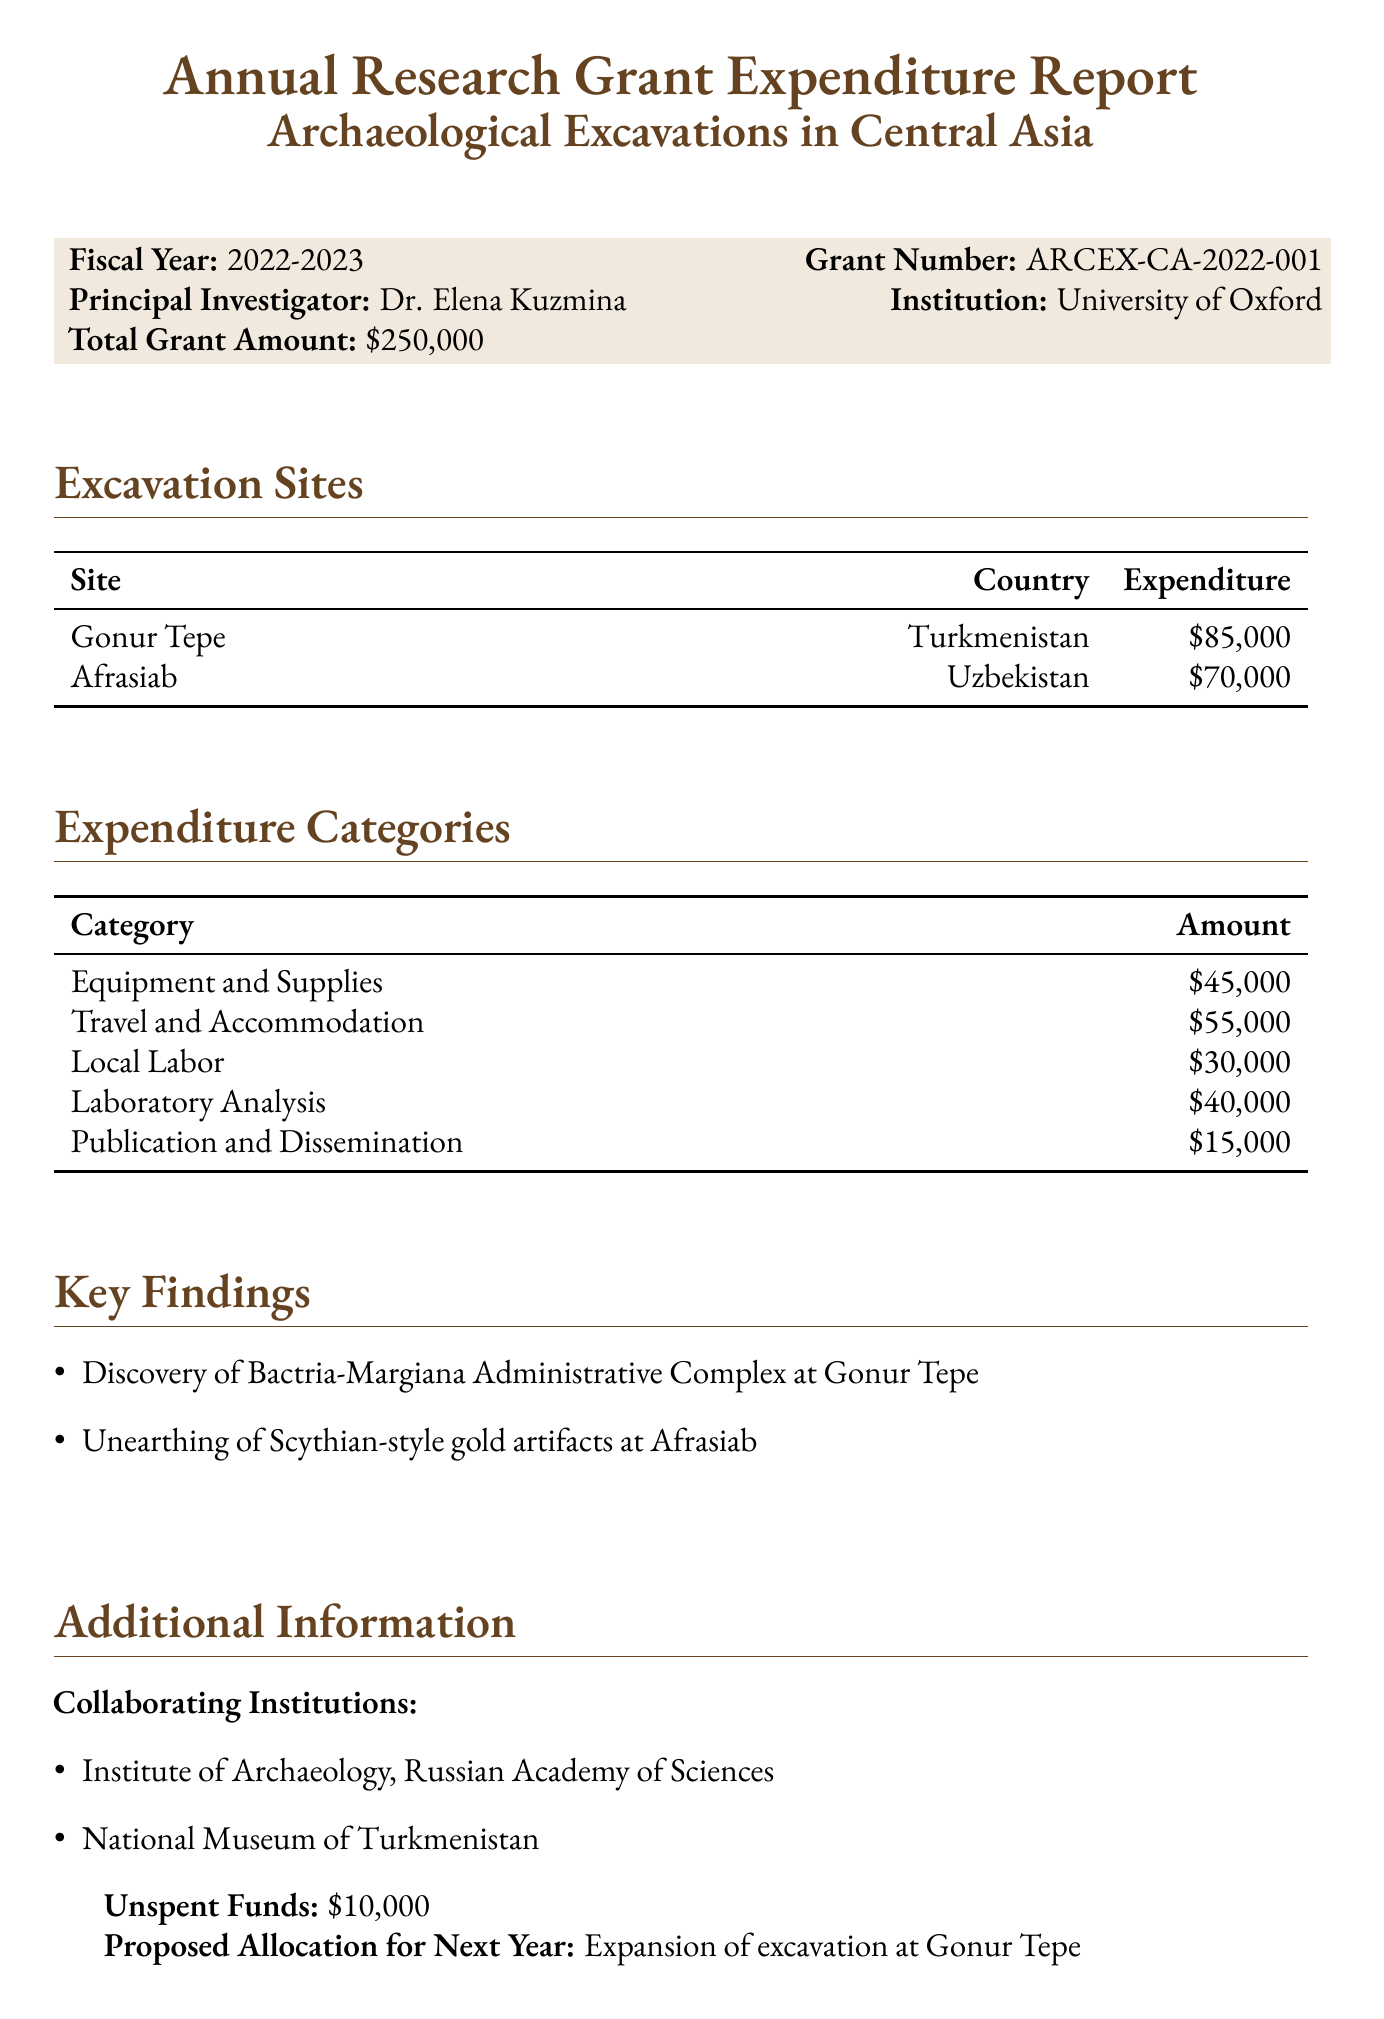What is the total grant amount? The total grant amount is specified in the document.
Answer: $250,000 Who is the principal investigator? The document mentions Dr. Elena Kuzmina as the principal investigator.
Answer: Dr. Elena Kuzmina Which site had the highest expenditure? By comparing the expenditures listed for each excavation site, Gonur Tepe has the highest expenditure.
Answer: Gonur Tepe What is the unspent fund amount? The document clearly states the amount of unspent funds.
Answer: $10,000 What is the proposed allocation for next year? The document outlines the proposed allocation for the next fiscal year.
Answer: Expansion of excavation at Gonur Tepe How much was spent on Travel and Accommodation? The amount spent in that category is provided in the expenditures section of the document.
Answer: $55,000 What key finding is associated with Afrasiab? The document specifies a key finding related to Afrasiab that can be directly cited.
Answer: Scythian-style gold artifacts What are two collaborating institutions? The document lists the institutions that collaborated on the excavation project.
Answer: Institute of Archaeology, Russian Academy of Sciences; National Museum of Turkmenistan What fiscal year does this report cover? The fiscal year covered in the report is stated at the beginning.
Answer: 2022-2023 